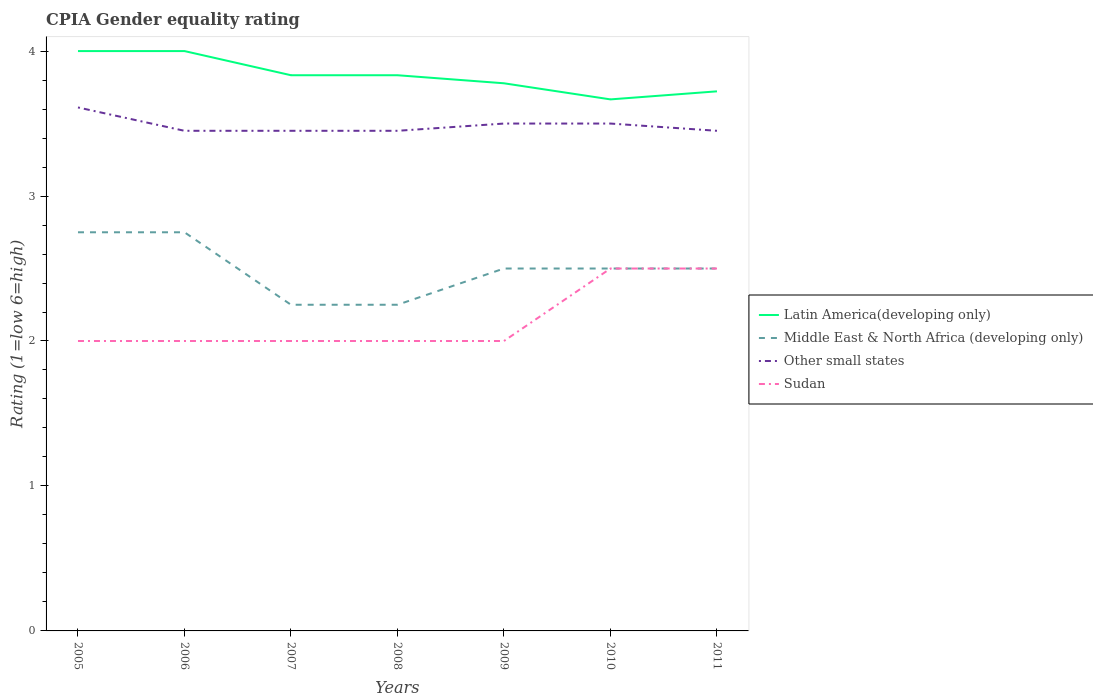Is the number of lines equal to the number of legend labels?
Ensure brevity in your answer.  Yes. Across all years, what is the maximum CPIA rating in Other small states?
Give a very brief answer. 3.45. Is the CPIA rating in Latin America(developing only) strictly greater than the CPIA rating in Sudan over the years?
Make the answer very short. No. How many lines are there?
Give a very brief answer. 4. How many years are there in the graph?
Ensure brevity in your answer.  7. Are the values on the major ticks of Y-axis written in scientific E-notation?
Offer a very short reply. No. Does the graph contain any zero values?
Offer a terse response. No. Does the graph contain grids?
Your answer should be compact. No. Where does the legend appear in the graph?
Your answer should be very brief. Center right. How many legend labels are there?
Give a very brief answer. 4. What is the title of the graph?
Your answer should be compact. CPIA Gender equality rating. What is the label or title of the X-axis?
Your answer should be very brief. Years. What is the Rating (1=low 6=high) of Middle East & North Africa (developing only) in 2005?
Offer a terse response. 2.75. What is the Rating (1=low 6=high) of Other small states in 2005?
Provide a succinct answer. 3.61. What is the Rating (1=low 6=high) of Sudan in 2005?
Your answer should be very brief. 2. What is the Rating (1=low 6=high) in Middle East & North Africa (developing only) in 2006?
Your response must be concise. 2.75. What is the Rating (1=low 6=high) in Other small states in 2006?
Offer a very short reply. 3.45. What is the Rating (1=low 6=high) of Latin America(developing only) in 2007?
Your response must be concise. 3.83. What is the Rating (1=low 6=high) of Middle East & North Africa (developing only) in 2007?
Provide a succinct answer. 2.25. What is the Rating (1=low 6=high) of Other small states in 2007?
Your answer should be compact. 3.45. What is the Rating (1=low 6=high) in Latin America(developing only) in 2008?
Provide a succinct answer. 3.83. What is the Rating (1=low 6=high) of Middle East & North Africa (developing only) in 2008?
Keep it short and to the point. 2.25. What is the Rating (1=low 6=high) in Other small states in 2008?
Offer a terse response. 3.45. What is the Rating (1=low 6=high) in Sudan in 2008?
Provide a short and direct response. 2. What is the Rating (1=low 6=high) in Latin America(developing only) in 2009?
Offer a very short reply. 3.78. What is the Rating (1=low 6=high) in Middle East & North Africa (developing only) in 2009?
Keep it short and to the point. 2.5. What is the Rating (1=low 6=high) in Sudan in 2009?
Offer a terse response. 2. What is the Rating (1=low 6=high) of Latin America(developing only) in 2010?
Give a very brief answer. 3.67. What is the Rating (1=low 6=high) in Middle East & North Africa (developing only) in 2010?
Provide a succinct answer. 2.5. What is the Rating (1=low 6=high) in Other small states in 2010?
Ensure brevity in your answer.  3.5. What is the Rating (1=low 6=high) in Sudan in 2010?
Provide a succinct answer. 2.5. What is the Rating (1=low 6=high) in Latin America(developing only) in 2011?
Make the answer very short. 3.72. What is the Rating (1=low 6=high) of Other small states in 2011?
Provide a succinct answer. 3.45. Across all years, what is the maximum Rating (1=low 6=high) in Latin America(developing only)?
Provide a succinct answer. 4. Across all years, what is the maximum Rating (1=low 6=high) of Middle East & North Africa (developing only)?
Keep it short and to the point. 2.75. Across all years, what is the maximum Rating (1=low 6=high) of Other small states?
Give a very brief answer. 3.61. Across all years, what is the minimum Rating (1=low 6=high) in Latin America(developing only)?
Provide a short and direct response. 3.67. Across all years, what is the minimum Rating (1=low 6=high) of Middle East & North Africa (developing only)?
Your response must be concise. 2.25. Across all years, what is the minimum Rating (1=low 6=high) of Other small states?
Your answer should be very brief. 3.45. Across all years, what is the minimum Rating (1=low 6=high) of Sudan?
Offer a very short reply. 2. What is the total Rating (1=low 6=high) in Latin America(developing only) in the graph?
Your answer should be very brief. 26.83. What is the total Rating (1=low 6=high) of Middle East & North Africa (developing only) in the graph?
Your answer should be very brief. 17.5. What is the total Rating (1=low 6=high) in Other small states in the graph?
Make the answer very short. 24.41. What is the difference between the Rating (1=low 6=high) in Other small states in 2005 and that in 2006?
Keep it short and to the point. 0.16. What is the difference between the Rating (1=low 6=high) in Sudan in 2005 and that in 2006?
Provide a short and direct response. 0. What is the difference between the Rating (1=low 6=high) in Latin America(developing only) in 2005 and that in 2007?
Your answer should be compact. 0.17. What is the difference between the Rating (1=low 6=high) of Other small states in 2005 and that in 2007?
Make the answer very short. 0.16. What is the difference between the Rating (1=low 6=high) of Sudan in 2005 and that in 2007?
Offer a terse response. 0. What is the difference between the Rating (1=low 6=high) of Latin America(developing only) in 2005 and that in 2008?
Give a very brief answer. 0.17. What is the difference between the Rating (1=low 6=high) of Other small states in 2005 and that in 2008?
Offer a very short reply. 0.16. What is the difference between the Rating (1=low 6=high) of Latin America(developing only) in 2005 and that in 2009?
Your answer should be very brief. 0.22. What is the difference between the Rating (1=low 6=high) in Middle East & North Africa (developing only) in 2005 and that in 2009?
Your answer should be compact. 0.25. What is the difference between the Rating (1=low 6=high) in Other small states in 2005 and that in 2009?
Offer a terse response. 0.11. What is the difference between the Rating (1=low 6=high) of Latin America(developing only) in 2005 and that in 2010?
Provide a short and direct response. 0.33. What is the difference between the Rating (1=low 6=high) of Middle East & North Africa (developing only) in 2005 and that in 2010?
Your answer should be compact. 0.25. What is the difference between the Rating (1=low 6=high) in Other small states in 2005 and that in 2010?
Keep it short and to the point. 0.11. What is the difference between the Rating (1=low 6=high) in Latin America(developing only) in 2005 and that in 2011?
Provide a succinct answer. 0.28. What is the difference between the Rating (1=low 6=high) of Middle East & North Africa (developing only) in 2005 and that in 2011?
Offer a terse response. 0.25. What is the difference between the Rating (1=low 6=high) of Other small states in 2005 and that in 2011?
Provide a succinct answer. 0.16. What is the difference between the Rating (1=low 6=high) in Latin America(developing only) in 2006 and that in 2007?
Give a very brief answer. 0.17. What is the difference between the Rating (1=low 6=high) of Sudan in 2006 and that in 2008?
Offer a terse response. 0. What is the difference between the Rating (1=low 6=high) in Latin America(developing only) in 2006 and that in 2009?
Your answer should be compact. 0.22. What is the difference between the Rating (1=low 6=high) of Middle East & North Africa (developing only) in 2006 and that in 2009?
Your answer should be very brief. 0.25. What is the difference between the Rating (1=low 6=high) of Other small states in 2006 and that in 2009?
Make the answer very short. -0.05. What is the difference between the Rating (1=low 6=high) of Sudan in 2006 and that in 2009?
Your response must be concise. 0. What is the difference between the Rating (1=low 6=high) of Latin America(developing only) in 2006 and that in 2010?
Your response must be concise. 0.33. What is the difference between the Rating (1=low 6=high) of Sudan in 2006 and that in 2010?
Keep it short and to the point. -0.5. What is the difference between the Rating (1=low 6=high) in Latin America(developing only) in 2006 and that in 2011?
Give a very brief answer. 0.28. What is the difference between the Rating (1=low 6=high) in Latin America(developing only) in 2007 and that in 2008?
Provide a succinct answer. 0. What is the difference between the Rating (1=low 6=high) of Middle East & North Africa (developing only) in 2007 and that in 2008?
Offer a terse response. 0. What is the difference between the Rating (1=low 6=high) of Latin America(developing only) in 2007 and that in 2009?
Your answer should be very brief. 0.06. What is the difference between the Rating (1=low 6=high) in Middle East & North Africa (developing only) in 2007 and that in 2009?
Offer a terse response. -0.25. What is the difference between the Rating (1=low 6=high) of Sudan in 2007 and that in 2009?
Give a very brief answer. 0. What is the difference between the Rating (1=low 6=high) in Latin America(developing only) in 2007 and that in 2010?
Give a very brief answer. 0.17. What is the difference between the Rating (1=low 6=high) in Middle East & North Africa (developing only) in 2007 and that in 2010?
Provide a succinct answer. -0.25. What is the difference between the Rating (1=low 6=high) in Latin America(developing only) in 2007 and that in 2011?
Provide a succinct answer. 0.11. What is the difference between the Rating (1=low 6=high) in Other small states in 2007 and that in 2011?
Your response must be concise. 0. What is the difference between the Rating (1=low 6=high) in Latin America(developing only) in 2008 and that in 2009?
Give a very brief answer. 0.06. What is the difference between the Rating (1=low 6=high) of Middle East & North Africa (developing only) in 2008 and that in 2009?
Give a very brief answer. -0.25. What is the difference between the Rating (1=low 6=high) of Sudan in 2008 and that in 2009?
Make the answer very short. 0. What is the difference between the Rating (1=low 6=high) in Latin America(developing only) in 2008 and that in 2010?
Your response must be concise. 0.17. What is the difference between the Rating (1=low 6=high) in Middle East & North Africa (developing only) in 2008 and that in 2010?
Offer a terse response. -0.25. What is the difference between the Rating (1=low 6=high) of Sudan in 2008 and that in 2010?
Your answer should be compact. -0.5. What is the difference between the Rating (1=low 6=high) of Latin America(developing only) in 2008 and that in 2011?
Provide a succinct answer. 0.11. What is the difference between the Rating (1=low 6=high) in Middle East & North Africa (developing only) in 2008 and that in 2011?
Provide a short and direct response. -0.25. What is the difference between the Rating (1=low 6=high) of Sudan in 2008 and that in 2011?
Ensure brevity in your answer.  -0.5. What is the difference between the Rating (1=low 6=high) in Latin America(developing only) in 2009 and that in 2010?
Your answer should be compact. 0.11. What is the difference between the Rating (1=low 6=high) of Middle East & North Africa (developing only) in 2009 and that in 2010?
Keep it short and to the point. 0. What is the difference between the Rating (1=low 6=high) in Sudan in 2009 and that in 2010?
Ensure brevity in your answer.  -0.5. What is the difference between the Rating (1=low 6=high) in Latin America(developing only) in 2009 and that in 2011?
Provide a short and direct response. 0.06. What is the difference between the Rating (1=low 6=high) of Sudan in 2009 and that in 2011?
Give a very brief answer. -0.5. What is the difference between the Rating (1=low 6=high) in Latin America(developing only) in 2010 and that in 2011?
Your answer should be very brief. -0.06. What is the difference between the Rating (1=low 6=high) of Latin America(developing only) in 2005 and the Rating (1=low 6=high) of Other small states in 2006?
Make the answer very short. 0.55. What is the difference between the Rating (1=low 6=high) in Latin America(developing only) in 2005 and the Rating (1=low 6=high) in Sudan in 2006?
Give a very brief answer. 2. What is the difference between the Rating (1=low 6=high) of Middle East & North Africa (developing only) in 2005 and the Rating (1=low 6=high) of Sudan in 2006?
Ensure brevity in your answer.  0.75. What is the difference between the Rating (1=low 6=high) in Other small states in 2005 and the Rating (1=low 6=high) in Sudan in 2006?
Offer a terse response. 1.61. What is the difference between the Rating (1=low 6=high) in Latin America(developing only) in 2005 and the Rating (1=low 6=high) in Other small states in 2007?
Offer a terse response. 0.55. What is the difference between the Rating (1=low 6=high) in Latin America(developing only) in 2005 and the Rating (1=low 6=high) in Sudan in 2007?
Provide a short and direct response. 2. What is the difference between the Rating (1=low 6=high) of Middle East & North Africa (developing only) in 2005 and the Rating (1=low 6=high) of Other small states in 2007?
Your response must be concise. -0.7. What is the difference between the Rating (1=low 6=high) of Other small states in 2005 and the Rating (1=low 6=high) of Sudan in 2007?
Provide a succinct answer. 1.61. What is the difference between the Rating (1=low 6=high) of Latin America(developing only) in 2005 and the Rating (1=low 6=high) of Other small states in 2008?
Your answer should be compact. 0.55. What is the difference between the Rating (1=low 6=high) in Latin America(developing only) in 2005 and the Rating (1=low 6=high) in Sudan in 2008?
Offer a very short reply. 2. What is the difference between the Rating (1=low 6=high) in Middle East & North Africa (developing only) in 2005 and the Rating (1=low 6=high) in Other small states in 2008?
Your response must be concise. -0.7. What is the difference between the Rating (1=low 6=high) in Other small states in 2005 and the Rating (1=low 6=high) in Sudan in 2008?
Provide a short and direct response. 1.61. What is the difference between the Rating (1=low 6=high) of Latin America(developing only) in 2005 and the Rating (1=low 6=high) of Other small states in 2009?
Provide a short and direct response. 0.5. What is the difference between the Rating (1=low 6=high) of Latin America(developing only) in 2005 and the Rating (1=low 6=high) of Sudan in 2009?
Keep it short and to the point. 2. What is the difference between the Rating (1=low 6=high) of Middle East & North Africa (developing only) in 2005 and the Rating (1=low 6=high) of Other small states in 2009?
Ensure brevity in your answer.  -0.75. What is the difference between the Rating (1=low 6=high) in Other small states in 2005 and the Rating (1=low 6=high) in Sudan in 2009?
Ensure brevity in your answer.  1.61. What is the difference between the Rating (1=low 6=high) in Middle East & North Africa (developing only) in 2005 and the Rating (1=low 6=high) in Other small states in 2010?
Your response must be concise. -0.75. What is the difference between the Rating (1=low 6=high) of Middle East & North Africa (developing only) in 2005 and the Rating (1=low 6=high) of Sudan in 2010?
Your answer should be very brief. 0.25. What is the difference between the Rating (1=low 6=high) in Latin America(developing only) in 2005 and the Rating (1=low 6=high) in Middle East & North Africa (developing only) in 2011?
Your answer should be compact. 1.5. What is the difference between the Rating (1=low 6=high) of Latin America(developing only) in 2005 and the Rating (1=low 6=high) of Other small states in 2011?
Provide a succinct answer. 0.55. What is the difference between the Rating (1=low 6=high) in Latin America(developing only) in 2005 and the Rating (1=low 6=high) in Sudan in 2011?
Your answer should be compact. 1.5. What is the difference between the Rating (1=low 6=high) of Middle East & North Africa (developing only) in 2005 and the Rating (1=low 6=high) of Other small states in 2011?
Ensure brevity in your answer.  -0.7. What is the difference between the Rating (1=low 6=high) in Latin America(developing only) in 2006 and the Rating (1=low 6=high) in Middle East & North Africa (developing only) in 2007?
Make the answer very short. 1.75. What is the difference between the Rating (1=low 6=high) of Latin America(developing only) in 2006 and the Rating (1=low 6=high) of Other small states in 2007?
Offer a very short reply. 0.55. What is the difference between the Rating (1=low 6=high) in Latin America(developing only) in 2006 and the Rating (1=low 6=high) in Sudan in 2007?
Offer a very short reply. 2. What is the difference between the Rating (1=low 6=high) in Middle East & North Africa (developing only) in 2006 and the Rating (1=low 6=high) in Other small states in 2007?
Give a very brief answer. -0.7. What is the difference between the Rating (1=low 6=high) of Middle East & North Africa (developing only) in 2006 and the Rating (1=low 6=high) of Sudan in 2007?
Your answer should be very brief. 0.75. What is the difference between the Rating (1=low 6=high) in Other small states in 2006 and the Rating (1=low 6=high) in Sudan in 2007?
Offer a very short reply. 1.45. What is the difference between the Rating (1=low 6=high) in Latin America(developing only) in 2006 and the Rating (1=low 6=high) in Other small states in 2008?
Provide a short and direct response. 0.55. What is the difference between the Rating (1=low 6=high) in Latin America(developing only) in 2006 and the Rating (1=low 6=high) in Sudan in 2008?
Offer a very short reply. 2. What is the difference between the Rating (1=low 6=high) of Middle East & North Africa (developing only) in 2006 and the Rating (1=low 6=high) of Other small states in 2008?
Make the answer very short. -0.7. What is the difference between the Rating (1=low 6=high) in Other small states in 2006 and the Rating (1=low 6=high) in Sudan in 2008?
Keep it short and to the point. 1.45. What is the difference between the Rating (1=low 6=high) in Latin America(developing only) in 2006 and the Rating (1=low 6=high) in Other small states in 2009?
Provide a succinct answer. 0.5. What is the difference between the Rating (1=low 6=high) in Middle East & North Africa (developing only) in 2006 and the Rating (1=low 6=high) in Other small states in 2009?
Your answer should be very brief. -0.75. What is the difference between the Rating (1=low 6=high) in Other small states in 2006 and the Rating (1=low 6=high) in Sudan in 2009?
Keep it short and to the point. 1.45. What is the difference between the Rating (1=low 6=high) in Latin America(developing only) in 2006 and the Rating (1=low 6=high) in Middle East & North Africa (developing only) in 2010?
Give a very brief answer. 1.5. What is the difference between the Rating (1=low 6=high) of Latin America(developing only) in 2006 and the Rating (1=low 6=high) of Other small states in 2010?
Your answer should be very brief. 0.5. What is the difference between the Rating (1=low 6=high) in Middle East & North Africa (developing only) in 2006 and the Rating (1=low 6=high) in Other small states in 2010?
Your answer should be compact. -0.75. What is the difference between the Rating (1=low 6=high) in Middle East & North Africa (developing only) in 2006 and the Rating (1=low 6=high) in Sudan in 2010?
Your response must be concise. 0.25. What is the difference between the Rating (1=low 6=high) of Other small states in 2006 and the Rating (1=low 6=high) of Sudan in 2010?
Your answer should be compact. 0.95. What is the difference between the Rating (1=low 6=high) of Latin America(developing only) in 2006 and the Rating (1=low 6=high) of Other small states in 2011?
Provide a short and direct response. 0.55. What is the difference between the Rating (1=low 6=high) of Latin America(developing only) in 2007 and the Rating (1=low 6=high) of Middle East & North Africa (developing only) in 2008?
Offer a very short reply. 1.58. What is the difference between the Rating (1=low 6=high) in Latin America(developing only) in 2007 and the Rating (1=low 6=high) in Other small states in 2008?
Provide a short and direct response. 0.38. What is the difference between the Rating (1=low 6=high) in Latin America(developing only) in 2007 and the Rating (1=low 6=high) in Sudan in 2008?
Your answer should be compact. 1.83. What is the difference between the Rating (1=low 6=high) in Middle East & North Africa (developing only) in 2007 and the Rating (1=low 6=high) in Sudan in 2008?
Your answer should be very brief. 0.25. What is the difference between the Rating (1=low 6=high) of Other small states in 2007 and the Rating (1=low 6=high) of Sudan in 2008?
Your answer should be very brief. 1.45. What is the difference between the Rating (1=low 6=high) in Latin America(developing only) in 2007 and the Rating (1=low 6=high) in Middle East & North Africa (developing only) in 2009?
Keep it short and to the point. 1.33. What is the difference between the Rating (1=low 6=high) in Latin America(developing only) in 2007 and the Rating (1=low 6=high) in Other small states in 2009?
Make the answer very short. 0.33. What is the difference between the Rating (1=low 6=high) of Latin America(developing only) in 2007 and the Rating (1=low 6=high) of Sudan in 2009?
Ensure brevity in your answer.  1.83. What is the difference between the Rating (1=low 6=high) in Middle East & North Africa (developing only) in 2007 and the Rating (1=low 6=high) in Other small states in 2009?
Your response must be concise. -1.25. What is the difference between the Rating (1=low 6=high) in Middle East & North Africa (developing only) in 2007 and the Rating (1=low 6=high) in Sudan in 2009?
Ensure brevity in your answer.  0.25. What is the difference between the Rating (1=low 6=high) in Other small states in 2007 and the Rating (1=low 6=high) in Sudan in 2009?
Give a very brief answer. 1.45. What is the difference between the Rating (1=low 6=high) of Middle East & North Africa (developing only) in 2007 and the Rating (1=low 6=high) of Other small states in 2010?
Ensure brevity in your answer.  -1.25. What is the difference between the Rating (1=low 6=high) of Middle East & North Africa (developing only) in 2007 and the Rating (1=low 6=high) of Sudan in 2010?
Provide a succinct answer. -0.25. What is the difference between the Rating (1=low 6=high) in Latin America(developing only) in 2007 and the Rating (1=low 6=high) in Other small states in 2011?
Provide a succinct answer. 0.38. What is the difference between the Rating (1=low 6=high) of Middle East & North Africa (developing only) in 2007 and the Rating (1=low 6=high) of Sudan in 2011?
Your response must be concise. -0.25. What is the difference between the Rating (1=low 6=high) in Latin America(developing only) in 2008 and the Rating (1=low 6=high) in Middle East & North Africa (developing only) in 2009?
Your answer should be compact. 1.33. What is the difference between the Rating (1=low 6=high) of Latin America(developing only) in 2008 and the Rating (1=low 6=high) of Other small states in 2009?
Make the answer very short. 0.33. What is the difference between the Rating (1=low 6=high) of Latin America(developing only) in 2008 and the Rating (1=low 6=high) of Sudan in 2009?
Provide a short and direct response. 1.83. What is the difference between the Rating (1=low 6=high) in Middle East & North Africa (developing only) in 2008 and the Rating (1=low 6=high) in Other small states in 2009?
Offer a terse response. -1.25. What is the difference between the Rating (1=low 6=high) in Other small states in 2008 and the Rating (1=low 6=high) in Sudan in 2009?
Make the answer very short. 1.45. What is the difference between the Rating (1=low 6=high) in Latin America(developing only) in 2008 and the Rating (1=low 6=high) in Other small states in 2010?
Make the answer very short. 0.33. What is the difference between the Rating (1=low 6=high) of Middle East & North Africa (developing only) in 2008 and the Rating (1=low 6=high) of Other small states in 2010?
Make the answer very short. -1.25. What is the difference between the Rating (1=low 6=high) in Middle East & North Africa (developing only) in 2008 and the Rating (1=low 6=high) in Sudan in 2010?
Your answer should be very brief. -0.25. What is the difference between the Rating (1=low 6=high) in Latin America(developing only) in 2008 and the Rating (1=low 6=high) in Other small states in 2011?
Your answer should be very brief. 0.38. What is the difference between the Rating (1=low 6=high) in Middle East & North Africa (developing only) in 2008 and the Rating (1=low 6=high) in Other small states in 2011?
Provide a succinct answer. -1.2. What is the difference between the Rating (1=low 6=high) of Middle East & North Africa (developing only) in 2008 and the Rating (1=low 6=high) of Sudan in 2011?
Give a very brief answer. -0.25. What is the difference between the Rating (1=low 6=high) in Other small states in 2008 and the Rating (1=low 6=high) in Sudan in 2011?
Your answer should be compact. 0.95. What is the difference between the Rating (1=low 6=high) of Latin America(developing only) in 2009 and the Rating (1=low 6=high) of Middle East & North Africa (developing only) in 2010?
Offer a terse response. 1.28. What is the difference between the Rating (1=low 6=high) of Latin America(developing only) in 2009 and the Rating (1=low 6=high) of Other small states in 2010?
Make the answer very short. 0.28. What is the difference between the Rating (1=low 6=high) in Latin America(developing only) in 2009 and the Rating (1=low 6=high) in Sudan in 2010?
Give a very brief answer. 1.28. What is the difference between the Rating (1=low 6=high) of Latin America(developing only) in 2009 and the Rating (1=low 6=high) of Middle East & North Africa (developing only) in 2011?
Your answer should be compact. 1.28. What is the difference between the Rating (1=low 6=high) in Latin America(developing only) in 2009 and the Rating (1=low 6=high) in Other small states in 2011?
Offer a terse response. 0.33. What is the difference between the Rating (1=low 6=high) of Latin America(developing only) in 2009 and the Rating (1=low 6=high) of Sudan in 2011?
Your response must be concise. 1.28. What is the difference between the Rating (1=low 6=high) in Middle East & North Africa (developing only) in 2009 and the Rating (1=low 6=high) in Other small states in 2011?
Provide a succinct answer. -0.95. What is the difference between the Rating (1=low 6=high) in Middle East & North Africa (developing only) in 2009 and the Rating (1=low 6=high) in Sudan in 2011?
Your response must be concise. 0. What is the difference between the Rating (1=low 6=high) in Other small states in 2009 and the Rating (1=low 6=high) in Sudan in 2011?
Offer a terse response. 1. What is the difference between the Rating (1=low 6=high) in Latin America(developing only) in 2010 and the Rating (1=low 6=high) in Other small states in 2011?
Offer a very short reply. 0.22. What is the difference between the Rating (1=low 6=high) of Middle East & North Africa (developing only) in 2010 and the Rating (1=low 6=high) of Other small states in 2011?
Offer a terse response. -0.95. What is the difference between the Rating (1=low 6=high) in Other small states in 2010 and the Rating (1=low 6=high) in Sudan in 2011?
Offer a very short reply. 1. What is the average Rating (1=low 6=high) in Latin America(developing only) per year?
Your answer should be compact. 3.83. What is the average Rating (1=low 6=high) in Middle East & North Africa (developing only) per year?
Provide a short and direct response. 2.5. What is the average Rating (1=low 6=high) in Other small states per year?
Your answer should be compact. 3.49. What is the average Rating (1=low 6=high) of Sudan per year?
Give a very brief answer. 2.14. In the year 2005, what is the difference between the Rating (1=low 6=high) of Latin America(developing only) and Rating (1=low 6=high) of Other small states?
Offer a very short reply. 0.39. In the year 2005, what is the difference between the Rating (1=low 6=high) of Middle East & North Africa (developing only) and Rating (1=low 6=high) of Other small states?
Offer a terse response. -0.86. In the year 2005, what is the difference between the Rating (1=low 6=high) of Middle East & North Africa (developing only) and Rating (1=low 6=high) of Sudan?
Your answer should be very brief. 0.75. In the year 2005, what is the difference between the Rating (1=low 6=high) of Other small states and Rating (1=low 6=high) of Sudan?
Your answer should be very brief. 1.61. In the year 2006, what is the difference between the Rating (1=low 6=high) of Latin America(developing only) and Rating (1=low 6=high) of Other small states?
Offer a very short reply. 0.55. In the year 2006, what is the difference between the Rating (1=low 6=high) in Middle East & North Africa (developing only) and Rating (1=low 6=high) in Other small states?
Provide a succinct answer. -0.7. In the year 2006, what is the difference between the Rating (1=low 6=high) of Other small states and Rating (1=low 6=high) of Sudan?
Offer a very short reply. 1.45. In the year 2007, what is the difference between the Rating (1=low 6=high) in Latin America(developing only) and Rating (1=low 6=high) in Middle East & North Africa (developing only)?
Offer a very short reply. 1.58. In the year 2007, what is the difference between the Rating (1=low 6=high) in Latin America(developing only) and Rating (1=low 6=high) in Other small states?
Your answer should be compact. 0.38. In the year 2007, what is the difference between the Rating (1=low 6=high) of Latin America(developing only) and Rating (1=low 6=high) of Sudan?
Your answer should be compact. 1.83. In the year 2007, what is the difference between the Rating (1=low 6=high) in Middle East & North Africa (developing only) and Rating (1=low 6=high) in Other small states?
Your answer should be very brief. -1.2. In the year 2007, what is the difference between the Rating (1=low 6=high) in Middle East & North Africa (developing only) and Rating (1=low 6=high) in Sudan?
Your response must be concise. 0.25. In the year 2007, what is the difference between the Rating (1=low 6=high) of Other small states and Rating (1=low 6=high) of Sudan?
Give a very brief answer. 1.45. In the year 2008, what is the difference between the Rating (1=low 6=high) in Latin America(developing only) and Rating (1=low 6=high) in Middle East & North Africa (developing only)?
Provide a succinct answer. 1.58. In the year 2008, what is the difference between the Rating (1=low 6=high) of Latin America(developing only) and Rating (1=low 6=high) of Other small states?
Make the answer very short. 0.38. In the year 2008, what is the difference between the Rating (1=low 6=high) of Latin America(developing only) and Rating (1=low 6=high) of Sudan?
Provide a succinct answer. 1.83. In the year 2008, what is the difference between the Rating (1=low 6=high) in Middle East & North Africa (developing only) and Rating (1=low 6=high) in Other small states?
Keep it short and to the point. -1.2. In the year 2008, what is the difference between the Rating (1=low 6=high) of Other small states and Rating (1=low 6=high) of Sudan?
Your response must be concise. 1.45. In the year 2009, what is the difference between the Rating (1=low 6=high) in Latin America(developing only) and Rating (1=low 6=high) in Middle East & North Africa (developing only)?
Provide a short and direct response. 1.28. In the year 2009, what is the difference between the Rating (1=low 6=high) of Latin America(developing only) and Rating (1=low 6=high) of Other small states?
Ensure brevity in your answer.  0.28. In the year 2009, what is the difference between the Rating (1=low 6=high) of Latin America(developing only) and Rating (1=low 6=high) of Sudan?
Give a very brief answer. 1.78. In the year 2009, what is the difference between the Rating (1=low 6=high) of Other small states and Rating (1=low 6=high) of Sudan?
Offer a very short reply. 1.5. In the year 2010, what is the difference between the Rating (1=low 6=high) of Latin America(developing only) and Rating (1=low 6=high) of Other small states?
Provide a succinct answer. 0.17. In the year 2010, what is the difference between the Rating (1=low 6=high) in Latin America(developing only) and Rating (1=low 6=high) in Sudan?
Provide a succinct answer. 1.17. In the year 2010, what is the difference between the Rating (1=low 6=high) of Middle East & North Africa (developing only) and Rating (1=low 6=high) of Other small states?
Provide a short and direct response. -1. In the year 2011, what is the difference between the Rating (1=low 6=high) in Latin America(developing only) and Rating (1=low 6=high) in Middle East & North Africa (developing only)?
Offer a very short reply. 1.22. In the year 2011, what is the difference between the Rating (1=low 6=high) in Latin America(developing only) and Rating (1=low 6=high) in Other small states?
Your answer should be compact. 0.27. In the year 2011, what is the difference between the Rating (1=low 6=high) in Latin America(developing only) and Rating (1=low 6=high) in Sudan?
Provide a short and direct response. 1.22. In the year 2011, what is the difference between the Rating (1=low 6=high) in Middle East & North Africa (developing only) and Rating (1=low 6=high) in Other small states?
Ensure brevity in your answer.  -0.95. What is the ratio of the Rating (1=low 6=high) of Other small states in 2005 to that in 2006?
Keep it short and to the point. 1.05. What is the ratio of the Rating (1=low 6=high) of Latin America(developing only) in 2005 to that in 2007?
Your answer should be compact. 1.04. What is the ratio of the Rating (1=low 6=high) of Middle East & North Africa (developing only) in 2005 to that in 2007?
Give a very brief answer. 1.22. What is the ratio of the Rating (1=low 6=high) in Other small states in 2005 to that in 2007?
Offer a terse response. 1.05. What is the ratio of the Rating (1=low 6=high) in Sudan in 2005 to that in 2007?
Your response must be concise. 1. What is the ratio of the Rating (1=low 6=high) of Latin America(developing only) in 2005 to that in 2008?
Offer a terse response. 1.04. What is the ratio of the Rating (1=low 6=high) of Middle East & North Africa (developing only) in 2005 to that in 2008?
Make the answer very short. 1.22. What is the ratio of the Rating (1=low 6=high) in Other small states in 2005 to that in 2008?
Keep it short and to the point. 1.05. What is the ratio of the Rating (1=low 6=high) in Sudan in 2005 to that in 2008?
Your answer should be very brief. 1. What is the ratio of the Rating (1=low 6=high) of Latin America(developing only) in 2005 to that in 2009?
Your answer should be compact. 1.06. What is the ratio of the Rating (1=low 6=high) of Other small states in 2005 to that in 2009?
Provide a short and direct response. 1.03. What is the ratio of the Rating (1=low 6=high) of Sudan in 2005 to that in 2009?
Your answer should be very brief. 1. What is the ratio of the Rating (1=low 6=high) of Latin America(developing only) in 2005 to that in 2010?
Your answer should be compact. 1.09. What is the ratio of the Rating (1=low 6=high) of Other small states in 2005 to that in 2010?
Keep it short and to the point. 1.03. What is the ratio of the Rating (1=low 6=high) in Sudan in 2005 to that in 2010?
Offer a terse response. 0.8. What is the ratio of the Rating (1=low 6=high) in Latin America(developing only) in 2005 to that in 2011?
Your response must be concise. 1.07. What is the ratio of the Rating (1=low 6=high) in Middle East & North Africa (developing only) in 2005 to that in 2011?
Offer a terse response. 1.1. What is the ratio of the Rating (1=low 6=high) of Other small states in 2005 to that in 2011?
Make the answer very short. 1.05. What is the ratio of the Rating (1=low 6=high) of Sudan in 2005 to that in 2011?
Your response must be concise. 0.8. What is the ratio of the Rating (1=low 6=high) of Latin America(developing only) in 2006 to that in 2007?
Offer a very short reply. 1.04. What is the ratio of the Rating (1=low 6=high) of Middle East & North Africa (developing only) in 2006 to that in 2007?
Give a very brief answer. 1.22. What is the ratio of the Rating (1=low 6=high) in Other small states in 2006 to that in 2007?
Your answer should be compact. 1. What is the ratio of the Rating (1=low 6=high) in Latin America(developing only) in 2006 to that in 2008?
Ensure brevity in your answer.  1.04. What is the ratio of the Rating (1=low 6=high) of Middle East & North Africa (developing only) in 2006 to that in 2008?
Offer a terse response. 1.22. What is the ratio of the Rating (1=low 6=high) of Sudan in 2006 to that in 2008?
Offer a terse response. 1. What is the ratio of the Rating (1=low 6=high) in Latin America(developing only) in 2006 to that in 2009?
Your response must be concise. 1.06. What is the ratio of the Rating (1=low 6=high) of Middle East & North Africa (developing only) in 2006 to that in 2009?
Keep it short and to the point. 1.1. What is the ratio of the Rating (1=low 6=high) of Other small states in 2006 to that in 2009?
Make the answer very short. 0.99. What is the ratio of the Rating (1=low 6=high) of Other small states in 2006 to that in 2010?
Offer a terse response. 0.99. What is the ratio of the Rating (1=low 6=high) of Latin America(developing only) in 2006 to that in 2011?
Your answer should be compact. 1.07. What is the ratio of the Rating (1=low 6=high) in Middle East & North Africa (developing only) in 2006 to that in 2011?
Offer a very short reply. 1.1. What is the ratio of the Rating (1=low 6=high) in Sudan in 2006 to that in 2011?
Provide a succinct answer. 0.8. What is the ratio of the Rating (1=low 6=high) in Middle East & North Africa (developing only) in 2007 to that in 2008?
Your answer should be very brief. 1. What is the ratio of the Rating (1=low 6=high) of Other small states in 2007 to that in 2008?
Provide a short and direct response. 1. What is the ratio of the Rating (1=low 6=high) in Latin America(developing only) in 2007 to that in 2009?
Offer a very short reply. 1.01. What is the ratio of the Rating (1=low 6=high) in Middle East & North Africa (developing only) in 2007 to that in 2009?
Ensure brevity in your answer.  0.9. What is the ratio of the Rating (1=low 6=high) in Other small states in 2007 to that in 2009?
Your answer should be very brief. 0.99. What is the ratio of the Rating (1=low 6=high) in Latin America(developing only) in 2007 to that in 2010?
Give a very brief answer. 1.05. What is the ratio of the Rating (1=low 6=high) in Middle East & North Africa (developing only) in 2007 to that in 2010?
Give a very brief answer. 0.9. What is the ratio of the Rating (1=low 6=high) of Other small states in 2007 to that in 2010?
Ensure brevity in your answer.  0.99. What is the ratio of the Rating (1=low 6=high) of Sudan in 2007 to that in 2010?
Give a very brief answer. 0.8. What is the ratio of the Rating (1=low 6=high) of Latin America(developing only) in 2007 to that in 2011?
Make the answer very short. 1.03. What is the ratio of the Rating (1=low 6=high) of Other small states in 2007 to that in 2011?
Make the answer very short. 1. What is the ratio of the Rating (1=low 6=high) of Latin America(developing only) in 2008 to that in 2009?
Your answer should be very brief. 1.01. What is the ratio of the Rating (1=low 6=high) of Middle East & North Africa (developing only) in 2008 to that in 2009?
Provide a succinct answer. 0.9. What is the ratio of the Rating (1=low 6=high) of Other small states in 2008 to that in 2009?
Your answer should be very brief. 0.99. What is the ratio of the Rating (1=low 6=high) in Sudan in 2008 to that in 2009?
Provide a succinct answer. 1. What is the ratio of the Rating (1=low 6=high) of Latin America(developing only) in 2008 to that in 2010?
Keep it short and to the point. 1.05. What is the ratio of the Rating (1=low 6=high) in Middle East & North Africa (developing only) in 2008 to that in 2010?
Keep it short and to the point. 0.9. What is the ratio of the Rating (1=low 6=high) in Other small states in 2008 to that in 2010?
Provide a short and direct response. 0.99. What is the ratio of the Rating (1=low 6=high) of Sudan in 2008 to that in 2010?
Offer a terse response. 0.8. What is the ratio of the Rating (1=low 6=high) in Latin America(developing only) in 2008 to that in 2011?
Ensure brevity in your answer.  1.03. What is the ratio of the Rating (1=low 6=high) of Middle East & North Africa (developing only) in 2008 to that in 2011?
Ensure brevity in your answer.  0.9. What is the ratio of the Rating (1=low 6=high) of Other small states in 2008 to that in 2011?
Keep it short and to the point. 1. What is the ratio of the Rating (1=low 6=high) in Latin America(developing only) in 2009 to that in 2010?
Offer a terse response. 1.03. What is the ratio of the Rating (1=low 6=high) in Middle East & North Africa (developing only) in 2009 to that in 2010?
Keep it short and to the point. 1. What is the ratio of the Rating (1=low 6=high) of Sudan in 2009 to that in 2010?
Your response must be concise. 0.8. What is the ratio of the Rating (1=low 6=high) of Latin America(developing only) in 2009 to that in 2011?
Your response must be concise. 1.01. What is the ratio of the Rating (1=low 6=high) in Middle East & North Africa (developing only) in 2009 to that in 2011?
Offer a very short reply. 1. What is the ratio of the Rating (1=low 6=high) in Other small states in 2009 to that in 2011?
Provide a succinct answer. 1.01. What is the ratio of the Rating (1=low 6=high) of Sudan in 2009 to that in 2011?
Your answer should be compact. 0.8. What is the ratio of the Rating (1=low 6=high) of Latin America(developing only) in 2010 to that in 2011?
Keep it short and to the point. 0.99. What is the ratio of the Rating (1=low 6=high) in Middle East & North Africa (developing only) in 2010 to that in 2011?
Provide a short and direct response. 1. What is the ratio of the Rating (1=low 6=high) of Other small states in 2010 to that in 2011?
Make the answer very short. 1.01. What is the difference between the highest and the second highest Rating (1=low 6=high) of Middle East & North Africa (developing only)?
Offer a terse response. 0. What is the difference between the highest and the second highest Rating (1=low 6=high) of Sudan?
Offer a terse response. 0. What is the difference between the highest and the lowest Rating (1=low 6=high) in Other small states?
Offer a very short reply. 0.16. What is the difference between the highest and the lowest Rating (1=low 6=high) of Sudan?
Keep it short and to the point. 0.5. 